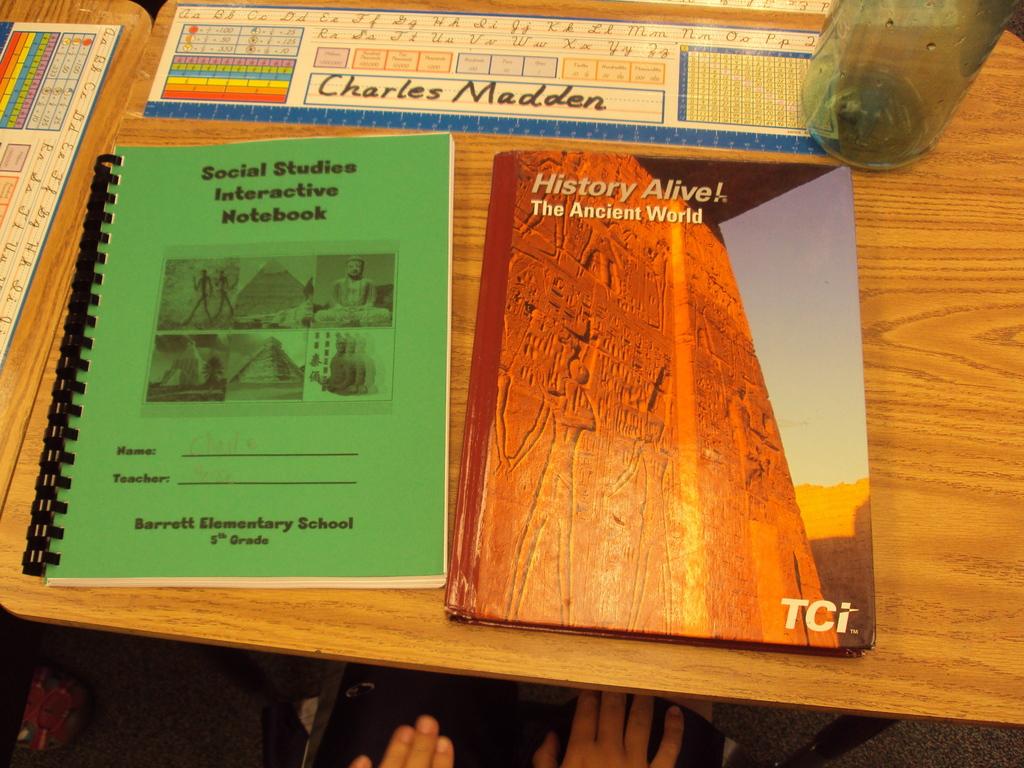What kind of social studies book is this?
Make the answer very short. Interactive notebook. 